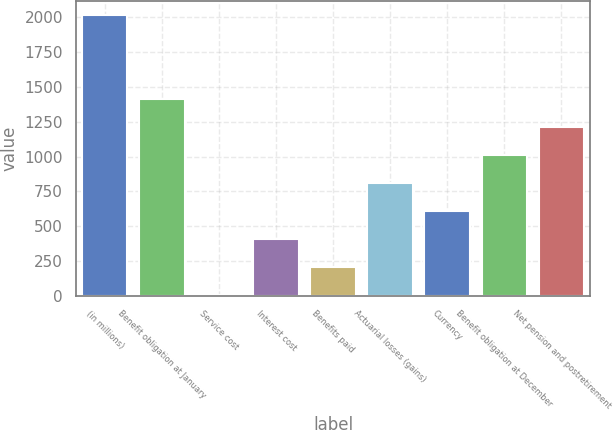Convert chart. <chart><loc_0><loc_0><loc_500><loc_500><bar_chart><fcel>(in millions)<fcel>Benefit obligation at January<fcel>Service cost<fcel>Interest cost<fcel>Benefits paid<fcel>Actuarial losses (gains)<fcel>Currency<fcel>Benefit obligation at December<fcel>Net pension and postretirement<nl><fcel>2018<fcel>1413.8<fcel>4<fcel>406.8<fcel>205.4<fcel>809.6<fcel>608.2<fcel>1011<fcel>1212.4<nl></chart> 